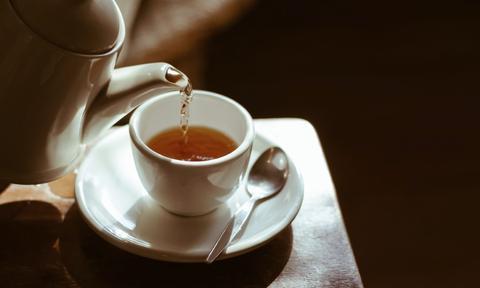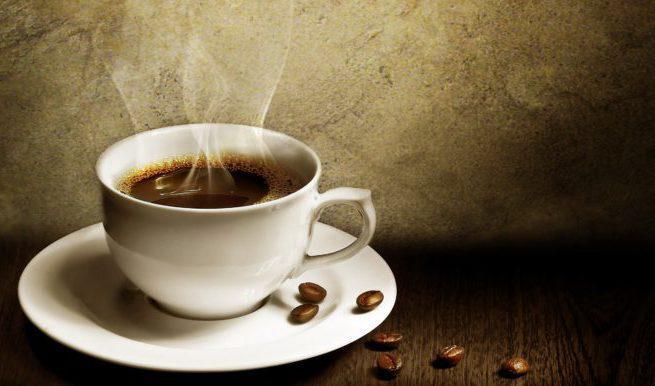The first image is the image on the left, the second image is the image on the right. Considering the images on both sides, is "Liquid is being poured into a cup in the left image of the pair." valid? Answer yes or no. Yes. The first image is the image on the left, the second image is the image on the right. For the images displayed, is the sentence "There are coffee beans in exactly one of the images." factually correct? Answer yes or no. Yes. 